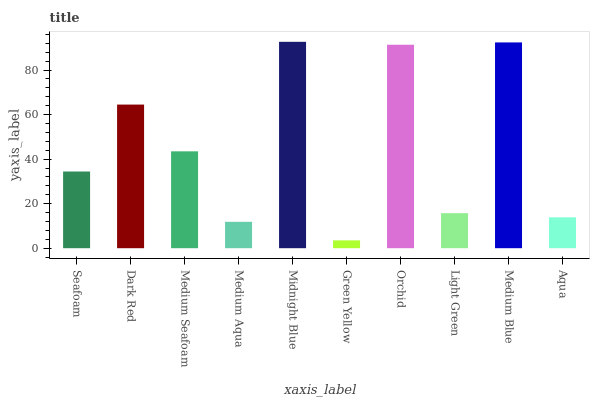Is Green Yellow the minimum?
Answer yes or no. Yes. Is Midnight Blue the maximum?
Answer yes or no. Yes. Is Dark Red the minimum?
Answer yes or no. No. Is Dark Red the maximum?
Answer yes or no. No. Is Dark Red greater than Seafoam?
Answer yes or no. Yes. Is Seafoam less than Dark Red?
Answer yes or no. Yes. Is Seafoam greater than Dark Red?
Answer yes or no. No. Is Dark Red less than Seafoam?
Answer yes or no. No. Is Medium Seafoam the high median?
Answer yes or no. Yes. Is Seafoam the low median?
Answer yes or no. Yes. Is Medium Aqua the high median?
Answer yes or no. No. Is Light Green the low median?
Answer yes or no. No. 